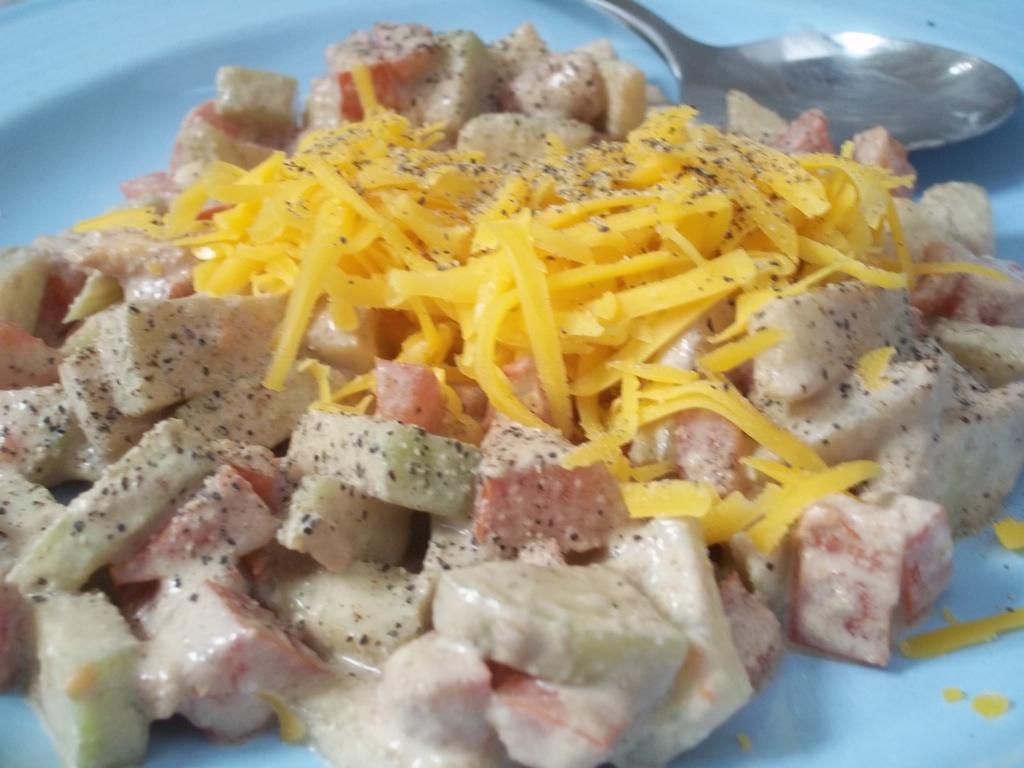What object is present on the plate in the image? There is a food item on the plate in the image. What color is the plate? The plate is white in color. What utensil is visible in the image? There is a spoon in the image. What type of powder can be seen on the plate in the image? There is no powder present on the plate in the image; it contains a food item. Is there a slope visible in the image? There is no slope present in the image. 